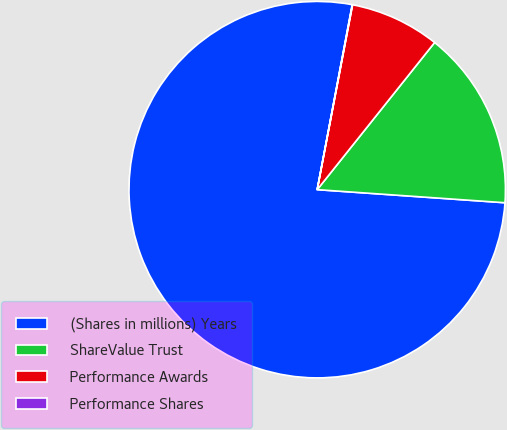<chart> <loc_0><loc_0><loc_500><loc_500><pie_chart><fcel>(Shares in millions) Years<fcel>ShareValue Trust<fcel>Performance Awards<fcel>Performance Shares<nl><fcel>76.87%<fcel>15.39%<fcel>7.71%<fcel>0.03%<nl></chart> 